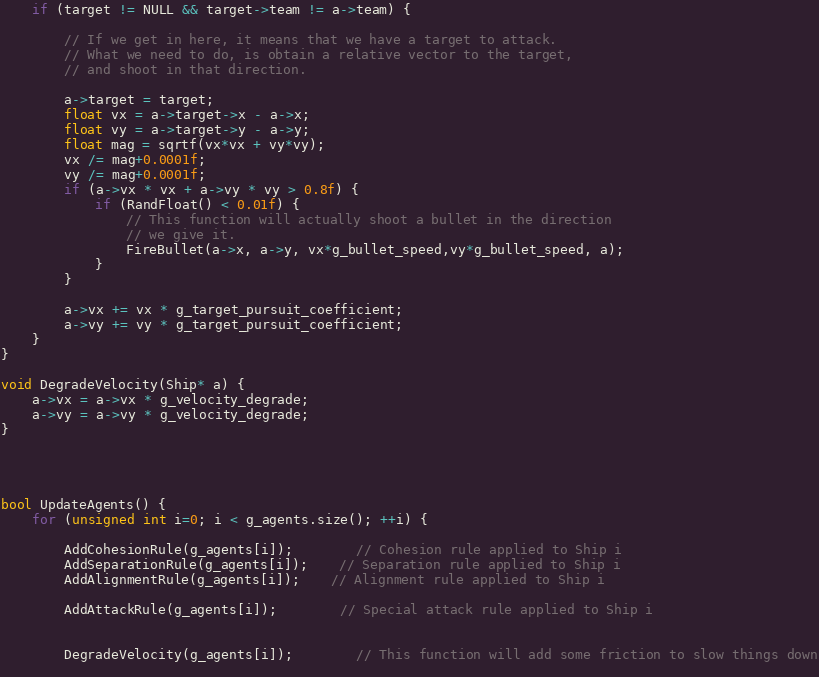<code> <loc_0><loc_0><loc_500><loc_500><_C++_>	if (target != NULL && target->team != a->team) {
		
		// If we get in here, it means that we have a target to attack.
		// What we need to do, is obtain a relative vector to the target,
		// and shoot in that direction.
		
		a->target = target;
		float vx = a->target->x - a->x;
		float vy = a->target->y - a->y;
		float mag = sqrtf(vx*vx + vy*vy);
		vx /= mag+0.0001f;
		vy /= mag+0.0001f;
		if (a->vx * vx + a->vy * vy > 0.8f) {
			if (RandFloat() < 0.01f) {
				// This function will actually shoot a bullet in the direction
				// we give it.
				FireBullet(a->x, a->y, vx*g_bullet_speed,vy*g_bullet_speed, a); 
			}
		}
		
		a->vx += vx * g_target_pursuit_coefficient;
		a->vy += vy * g_target_pursuit_coefficient;
	}
}

void DegradeVelocity(Ship* a) {
	a->vx = a->vx * g_velocity_degrade;
	a->vy = a->vy * g_velocity_degrade;
}




bool UpdateAgents() {
	for (unsigned int i=0; i < g_agents.size(); ++i) {
		
		AddCohesionRule(g_agents[i]);		// Cohesion rule applied to Ship i
		AddSeparationRule(g_agents[i]);	// Separation rule applied to Ship i
		AddAlignmentRule(g_agents[i]);	// Alignment rule applied to Ship i
		
		AddAttackRule(g_agents[i]);		// Special attack rule applied to Ship i
	
		
		DegradeVelocity(g_agents[i]);		// This function will add some friction to slow things down
				</code> 